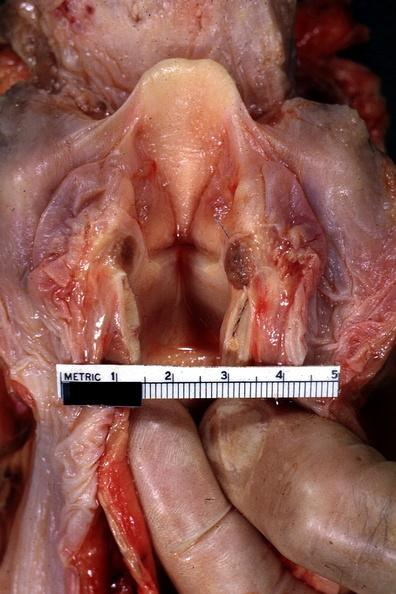s edema hypopharynx present?
Answer the question using a single word or phrase. Yes 